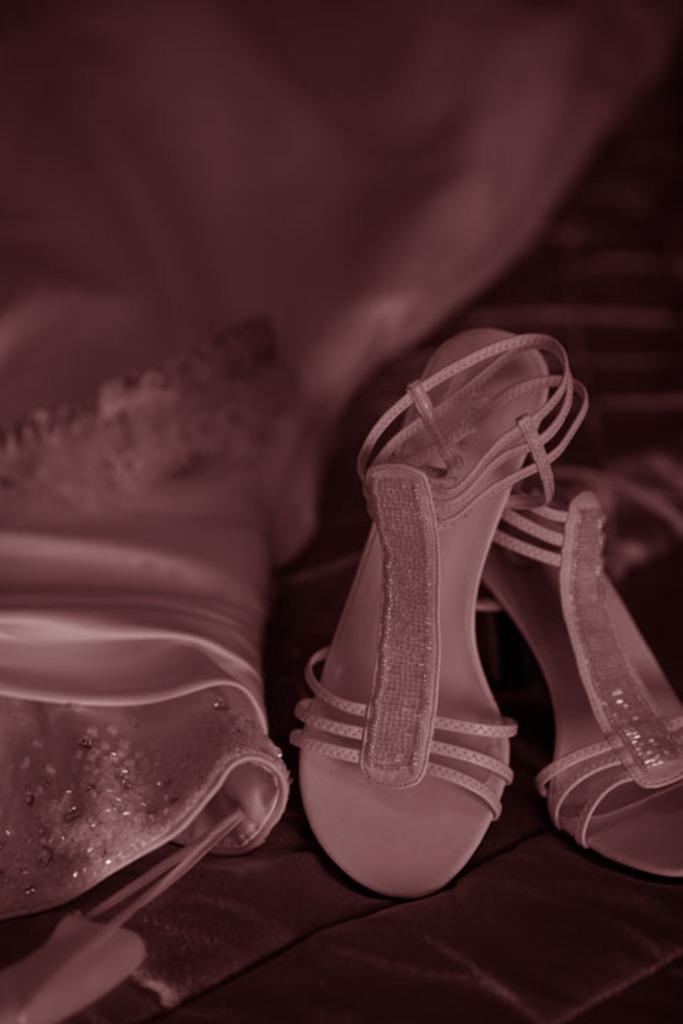Please provide a concise description of this image. In the image there is a pink footwear and beside the footwear there is a matching color dress. 